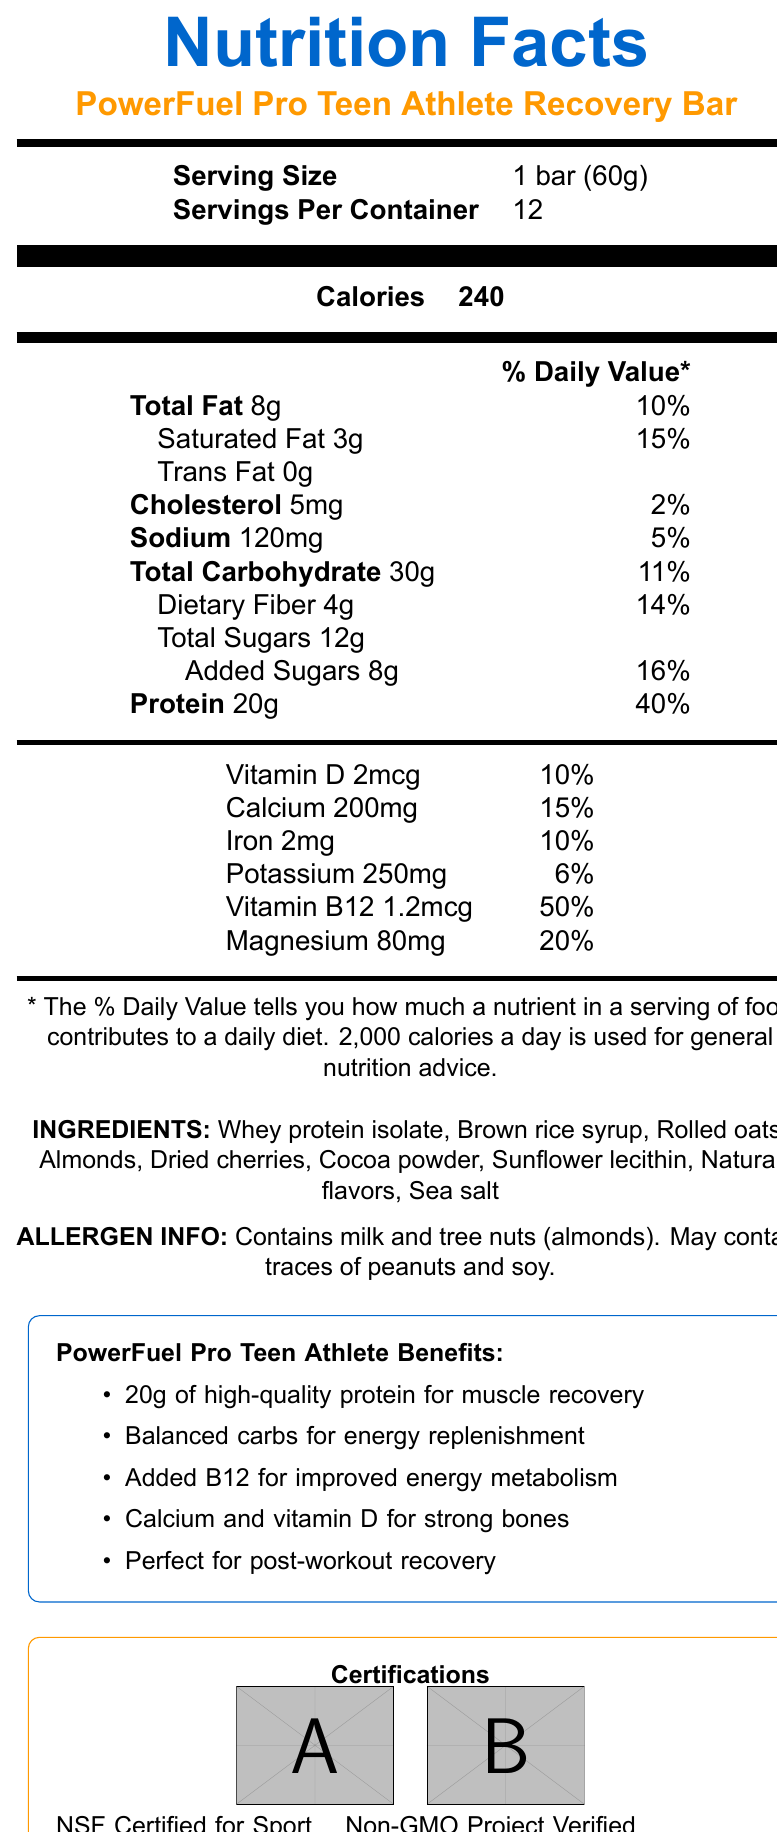What is the serving size for the PowerFuel Pro Teen Athlete Recovery Bar? The serving size is listed at the beginning of the Nutrition Facts section.
Answer: 1 bar (60g) How many calories are there per serving? The calories per serving are clearly stated as 240.
Answer: 240 What is the amount of protein in one bar? The protein content per serving is specified as 20g.
Answer: 20g How much dietary fiber does one bar contain? The dietary fiber amount can be found in the Nutrition Facts under total carbohydrate.
Answer: 4g How much calcium is present in one bar and what percentage of the daily value does it represent? The calcium content is listed under vitamins and minerals with its daily value percentage.
Answer: 200mg, 15% Does the bar contain any saturated fat? The Nutrition Facts indicate that each bar contains 3g of saturated fat.
Answer: Yes How many servings are there per container? The servings per container are listed near the top of the Nutrition Facts.
Answer: 12 What allergens are present in the PowerFuel Pro Teen Athlete Recovery Bar? The allergen information is provided below the ingredients list.
Answer: Milk and tree nuts (almonds). May contain traces of peanuts and soy. Which vitamins and minerals in the bar have the highest daily value percentages? A. Vitamin D and Calcium B. Calcium and Iron C. Vitamin B12 and Magnesium D. Iron and Potassium Vitamin B12 has a daily value of 50%, and Magnesium has a daily value of 20%, which are the highest in the list provided.
Answer: C What is the product name of the bar? The product name is mentioned prominently in the header of the document.
Answer: PowerFuel Pro Teen Athlete Recovery Bar How much sodium does the bar contain? A. 50 mg B. 100 mg C. 120 mg D. 150 mg The sodium content is listed as 120 mg in the Nutrition Facts.
Answer: C Can it be determined if this product is gluten-free based on the document? There is no specific information regarding gluten in the ingredients list or allergen info.
Answer: Not enough information Is this product NSF Certified for Sport? The document mentions that the product is NSF Certified for Sport, shown in the certifications section.
Answer: Yes Describe the main benefits of the PowerFuel Pro Teen Athlete Recovery Bar according to the document. The main benefits are summarized in the marketing claims, emphasizing its formulation for teen athletes and key nutritional benefits.
Answer: This product is specially formulated for teen athletes. It contains 20g of high-quality protein for muscle recovery, balanced carbs for energy replenishment, added B12 for improved energy metabolism, and calcium and vitamin D for strong bones. It is perfect for post-workout recovery. What are the marketing claims made about this protein bar? The marketing claims are listed towards the end of the document under "PowerFuel Pro Teen Athlete Benefits."
Answer: Specially formulated for teen athletes, 20g of high-quality protein for muscle recovery, balanced carbs for energy replenishment, added B12 for improved energy metabolism, calcium and vitamin D for strong bones, perfect for post-workout recovery after intense practices or games. Does the bar contain any trans fat? The Nutrition Facts state that the bar contains 0g of trans fat.
Answer: No 